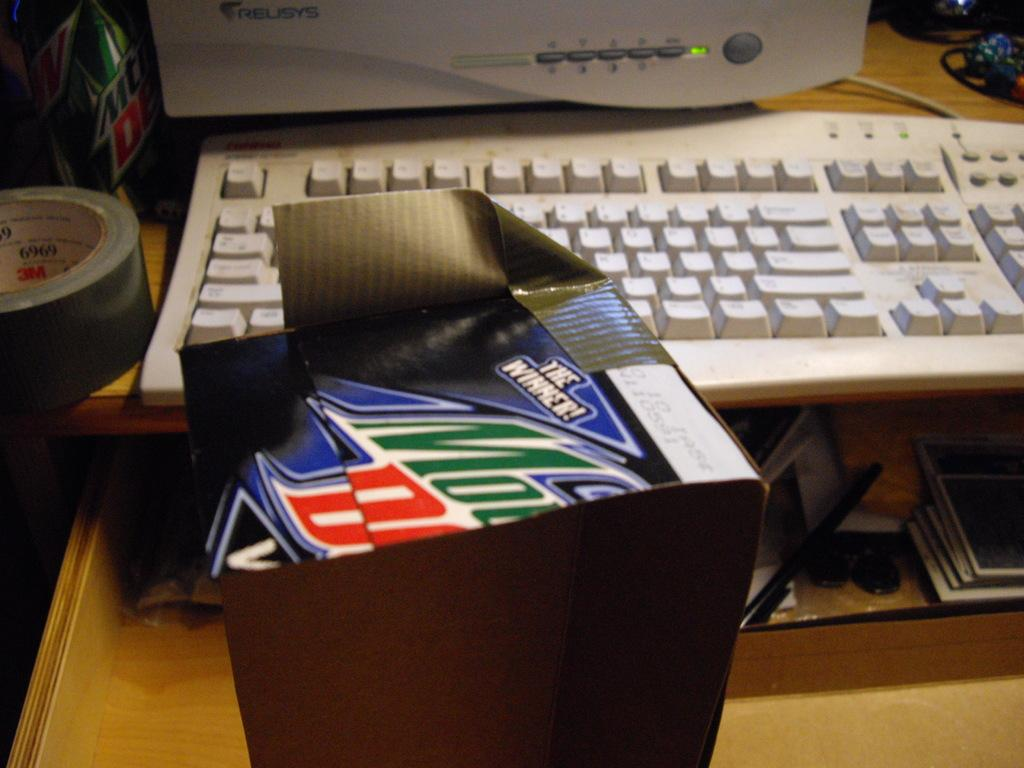What is on the table in the image? There is a box, a monitor, and a keyboard on the table in the image. Can you describe the box on the table? The box is on the table, but no further details about its appearance or contents are provided. What is the purpose of the monitor on the table? The purpose of the monitor is not specified in the image, but it is likely used for displaying information or visuals. What is the keyboard used for in the image? The keyboard is likely used for inputting data or commands into a computer or device connected to the monitor. Where is the boy sitting in the image? There is no boy present in the image; it only features a box, a monitor, and a keyboard on a table. What type of pipe is visible in the image? There is no pipe present in the image. 